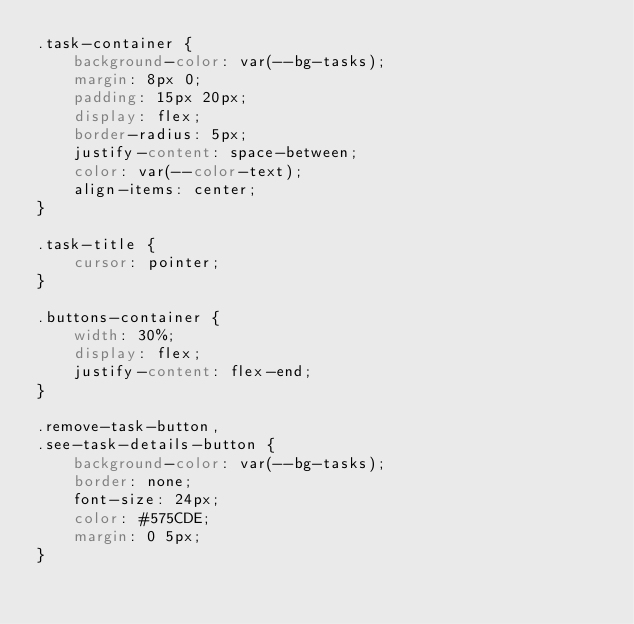<code> <loc_0><loc_0><loc_500><loc_500><_CSS_>.task-container {
	background-color: var(--bg-tasks);
	margin: 8px 0;
	padding: 15px 20px;
	display: flex;
	border-radius: 5px;
	justify-content: space-between;
	color: var(--color-text);
	align-items: center;
}

.task-title {
	cursor: pointer;
}

.buttons-container {
	width: 30%;
	display: flex;
	justify-content: flex-end;
}

.remove-task-button,
.see-task-details-button {
	background-color: var(--bg-tasks);
	border: none;
	font-size: 24px;
	color: #575CDE;
	margin: 0 5px;
}
</code> 